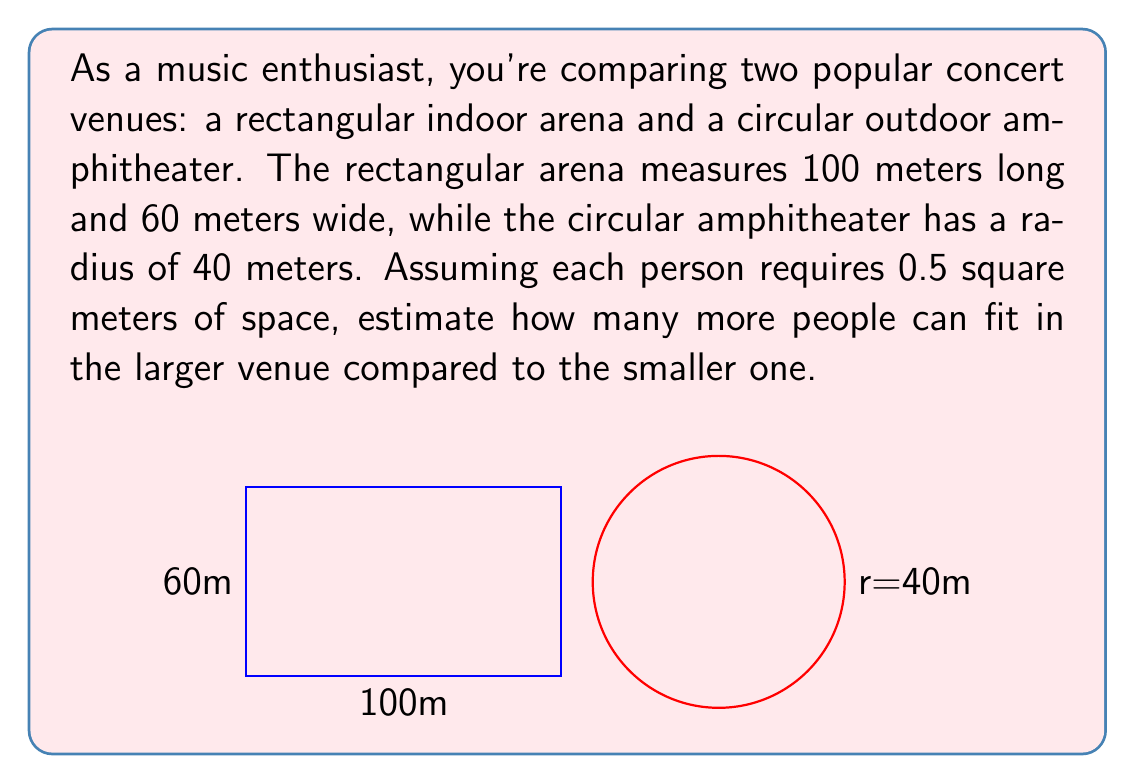Can you answer this question? Let's approach this step-by-step:

1) First, calculate the area of the rectangular arena:
   $$ A_{rectangle} = length \times width = 100m \times 60m = 6000m^2 $$

2) Now, calculate the area of the circular amphitheater:
   $$ A_{circle} = \pi r^2 = \pi \times (40m)^2 = 1600\pi m^2 \approx 5026.55m^2 $$

3) To find the number of people that can fit in each venue, divide the area by the space required per person (0.5 m²):

   For the rectangular arena:
   $$ N_{rectangle} = \frac{6000m^2}{0.5m^2/person} = 12000 \text{ people} $$

   For the circular amphitheater:
   $$ N_{circle} = \frac{5026.55m^2}{0.5m^2/person} \approx 10053 \text{ people} $$

4) To find how many more people can fit in the larger venue, subtract:
   $$ Difference = 12000 - 10053 = 1947 \text{ people} $$

Therefore, the rectangular arena can fit approximately 1947 more people than the circular amphitheater.
Answer: 1947 people 